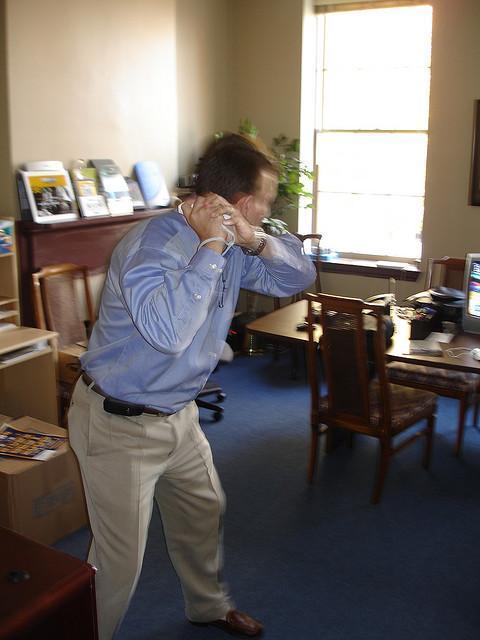How many chairs can you see?
Give a very brief answer. 3. How many books are visible?
Give a very brief answer. 2. 